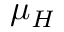Convert formula to latex. <formula><loc_0><loc_0><loc_500><loc_500>\mu _ { H }</formula> 